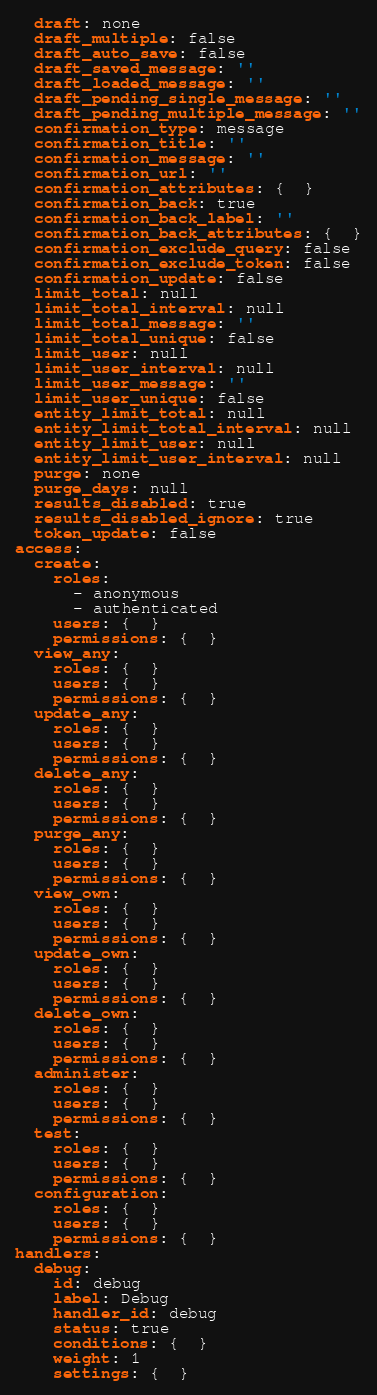<code> <loc_0><loc_0><loc_500><loc_500><_YAML_>  draft: none
  draft_multiple: false
  draft_auto_save: false
  draft_saved_message: ''
  draft_loaded_message: ''
  draft_pending_single_message: ''
  draft_pending_multiple_message: ''
  confirmation_type: message
  confirmation_title: ''
  confirmation_message: ''
  confirmation_url: ''
  confirmation_attributes: {  }
  confirmation_back: true
  confirmation_back_label: ''
  confirmation_back_attributes: {  }
  confirmation_exclude_query: false
  confirmation_exclude_token: false
  confirmation_update: false
  limit_total: null
  limit_total_interval: null
  limit_total_message: ''
  limit_total_unique: false
  limit_user: null
  limit_user_interval: null
  limit_user_message: ''
  limit_user_unique: false
  entity_limit_total: null
  entity_limit_total_interval: null
  entity_limit_user: null
  entity_limit_user_interval: null
  purge: none
  purge_days: null
  results_disabled: true
  results_disabled_ignore: true
  token_update: false
access:
  create:
    roles:
      - anonymous
      - authenticated
    users: {  }
    permissions: {  }
  view_any:
    roles: {  }
    users: {  }
    permissions: {  }
  update_any:
    roles: {  }
    users: {  }
    permissions: {  }
  delete_any:
    roles: {  }
    users: {  }
    permissions: {  }
  purge_any:
    roles: {  }
    users: {  }
    permissions: {  }
  view_own:
    roles: {  }
    users: {  }
    permissions: {  }
  update_own:
    roles: {  }
    users: {  }
    permissions: {  }
  delete_own:
    roles: {  }
    users: {  }
    permissions: {  }
  administer:
    roles: {  }
    users: {  }
    permissions: {  }
  test:
    roles: {  }
    users: {  }
    permissions: {  }
  configuration:
    roles: {  }
    users: {  }
    permissions: {  }
handlers:
  debug:
    id: debug
    label: Debug
    handler_id: debug
    status: true
    conditions: {  }
    weight: 1
    settings: {  }
</code> 